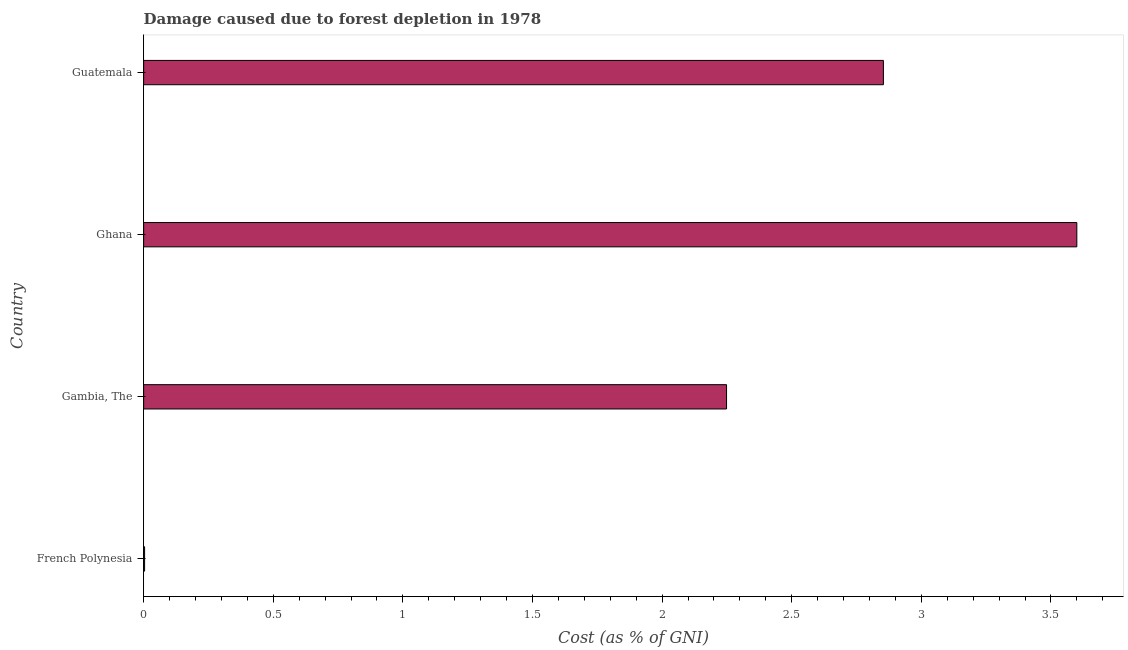Does the graph contain grids?
Your answer should be compact. No. What is the title of the graph?
Your answer should be compact. Damage caused due to forest depletion in 1978. What is the label or title of the X-axis?
Offer a very short reply. Cost (as % of GNI). What is the damage caused due to forest depletion in French Polynesia?
Offer a very short reply. 0. Across all countries, what is the maximum damage caused due to forest depletion?
Your answer should be very brief. 3.6. Across all countries, what is the minimum damage caused due to forest depletion?
Your response must be concise. 0. In which country was the damage caused due to forest depletion minimum?
Make the answer very short. French Polynesia. What is the sum of the damage caused due to forest depletion?
Give a very brief answer. 8.71. What is the difference between the damage caused due to forest depletion in Ghana and Guatemala?
Offer a very short reply. 0.75. What is the average damage caused due to forest depletion per country?
Provide a short and direct response. 2.18. What is the median damage caused due to forest depletion?
Keep it short and to the point. 2.55. In how many countries, is the damage caused due to forest depletion greater than 3.6 %?
Your answer should be compact. 0. What is the ratio of the damage caused due to forest depletion in Gambia, The to that in Guatemala?
Ensure brevity in your answer.  0.79. Is the damage caused due to forest depletion in Ghana less than that in Guatemala?
Ensure brevity in your answer.  No. What is the difference between the highest and the second highest damage caused due to forest depletion?
Provide a short and direct response. 0.75. Is the sum of the damage caused due to forest depletion in French Polynesia and Guatemala greater than the maximum damage caused due to forest depletion across all countries?
Provide a succinct answer. No. What is the difference between the highest and the lowest damage caused due to forest depletion?
Your response must be concise. 3.6. How many bars are there?
Give a very brief answer. 4. How many countries are there in the graph?
Offer a terse response. 4. Are the values on the major ticks of X-axis written in scientific E-notation?
Your answer should be very brief. No. What is the Cost (as % of GNI) of French Polynesia?
Provide a short and direct response. 0. What is the Cost (as % of GNI) of Gambia, The?
Ensure brevity in your answer.  2.25. What is the Cost (as % of GNI) of Ghana?
Keep it short and to the point. 3.6. What is the Cost (as % of GNI) in Guatemala?
Keep it short and to the point. 2.85. What is the difference between the Cost (as % of GNI) in French Polynesia and Gambia, The?
Give a very brief answer. -2.24. What is the difference between the Cost (as % of GNI) in French Polynesia and Ghana?
Keep it short and to the point. -3.6. What is the difference between the Cost (as % of GNI) in French Polynesia and Guatemala?
Keep it short and to the point. -2.85. What is the difference between the Cost (as % of GNI) in Gambia, The and Ghana?
Provide a succinct answer. -1.35. What is the difference between the Cost (as % of GNI) in Gambia, The and Guatemala?
Provide a succinct answer. -0.61. What is the difference between the Cost (as % of GNI) in Ghana and Guatemala?
Keep it short and to the point. 0.75. What is the ratio of the Cost (as % of GNI) in French Polynesia to that in Gambia, The?
Provide a short and direct response. 0. What is the ratio of the Cost (as % of GNI) in French Polynesia to that in Guatemala?
Your response must be concise. 0. What is the ratio of the Cost (as % of GNI) in Gambia, The to that in Guatemala?
Your response must be concise. 0.79. What is the ratio of the Cost (as % of GNI) in Ghana to that in Guatemala?
Give a very brief answer. 1.26. 